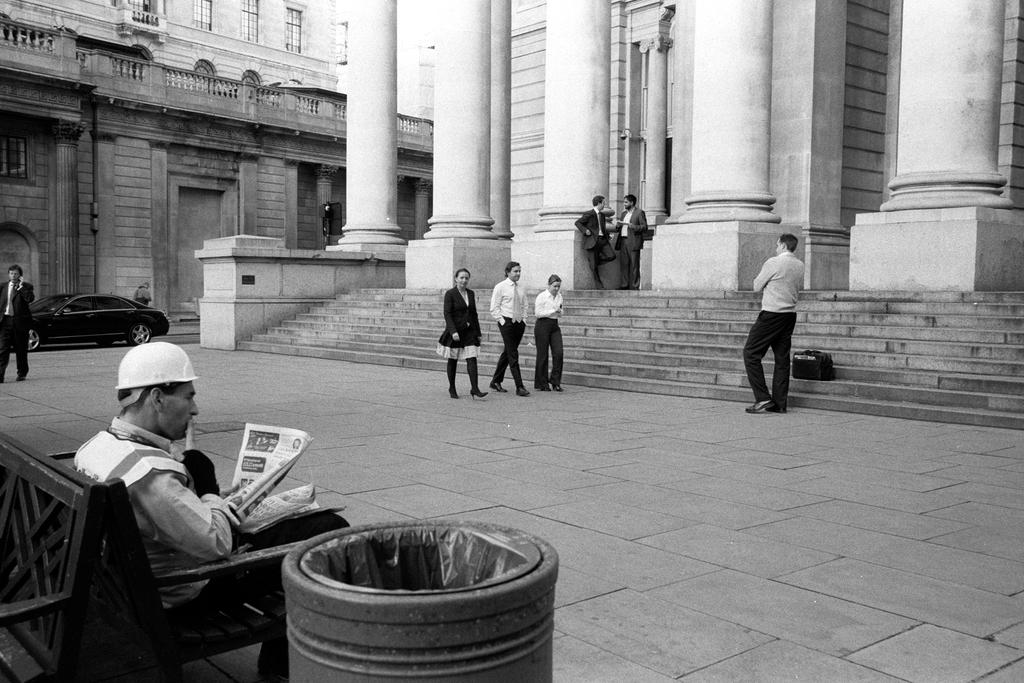How many people are in the image? There is a group of people in the image. What are some of the people in the image doing? Some people are walking, some are standing, and one person is sitting on a sofa. What can be seen in the background of the image? There are buildings and a car visible in the background of the image. What type of bottle can be seen in the image? There is no bottle present in the image. What does the image smell like? The image does not have a smell, as it is a visual representation. 